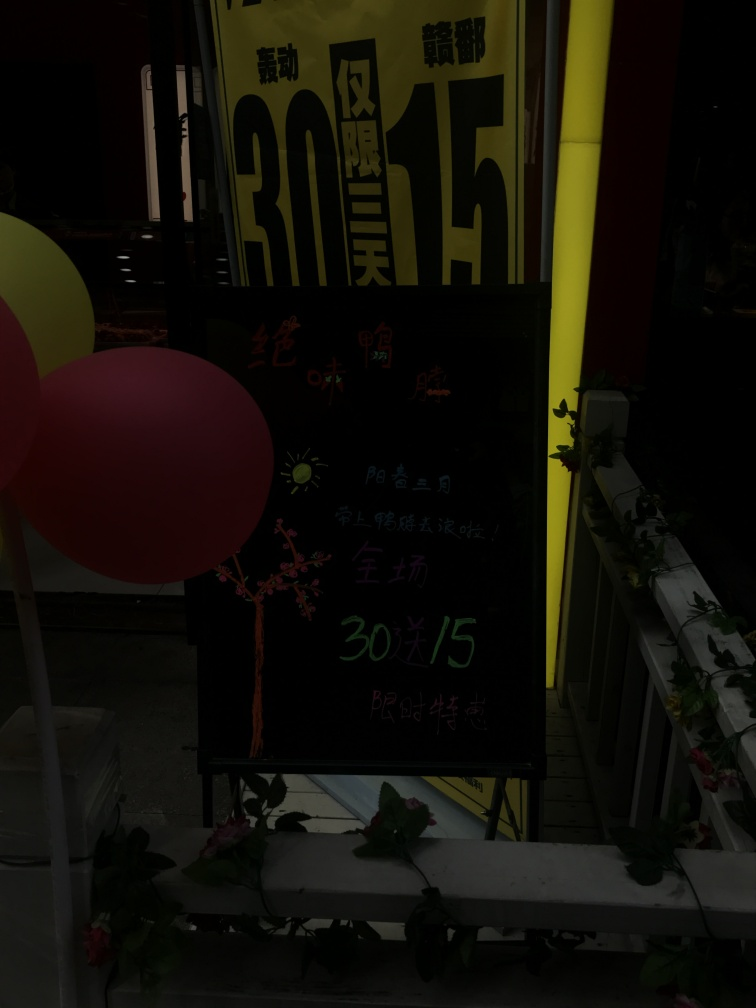What kind of establishment is this sign associated with? The sign seems to be related to a dining establishment or a place that offers meals, as suggested by the numerical values which could indicate prices. However, due to the poor lighting it's difficult to confirm the specifics without additional context. Can you tell me more about the location? The location is not immediately discernible from the image itself, but the style of the sign, the characters, and the ambiance suggest that it could be situated in a region where the primary language is Chinese. As for the specific setting, we may conjecture it is in an urban environment given the signage and artificial lighting. 